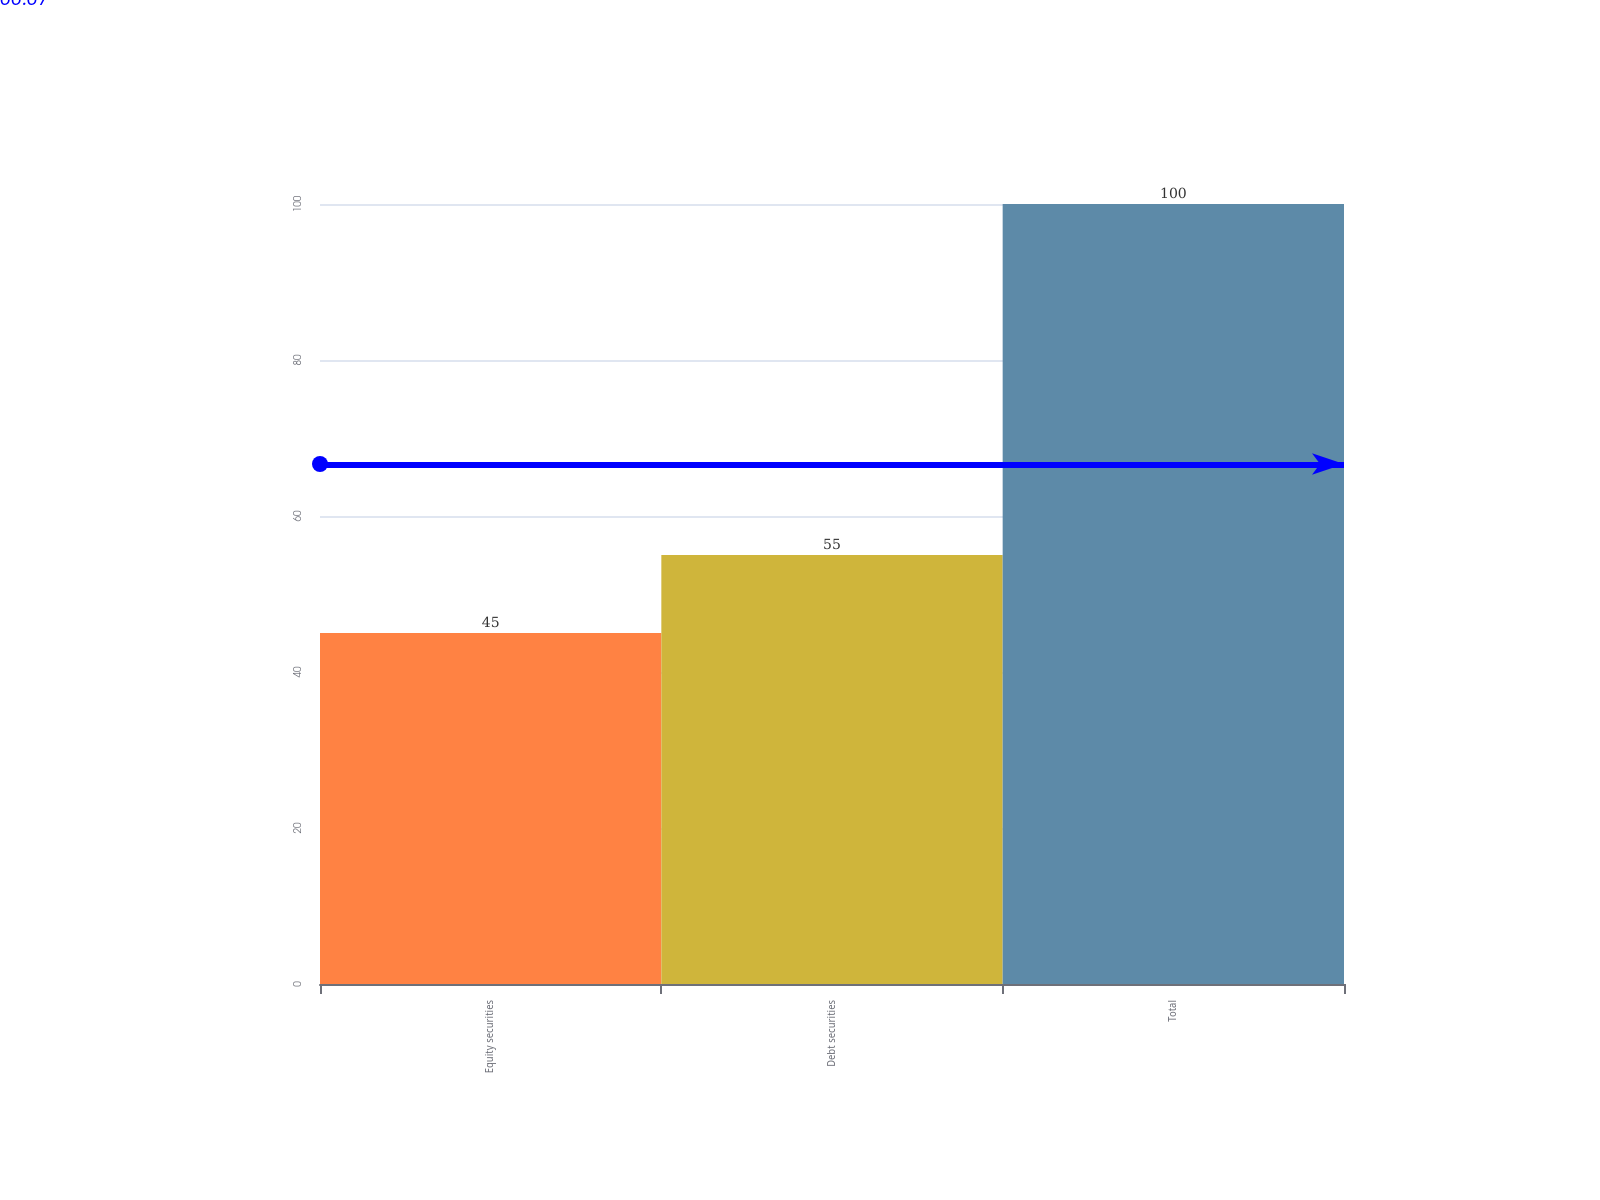Convert chart. <chart><loc_0><loc_0><loc_500><loc_500><bar_chart><fcel>Equity securities<fcel>Debt securities<fcel>Total<nl><fcel>45<fcel>55<fcel>100<nl></chart> 